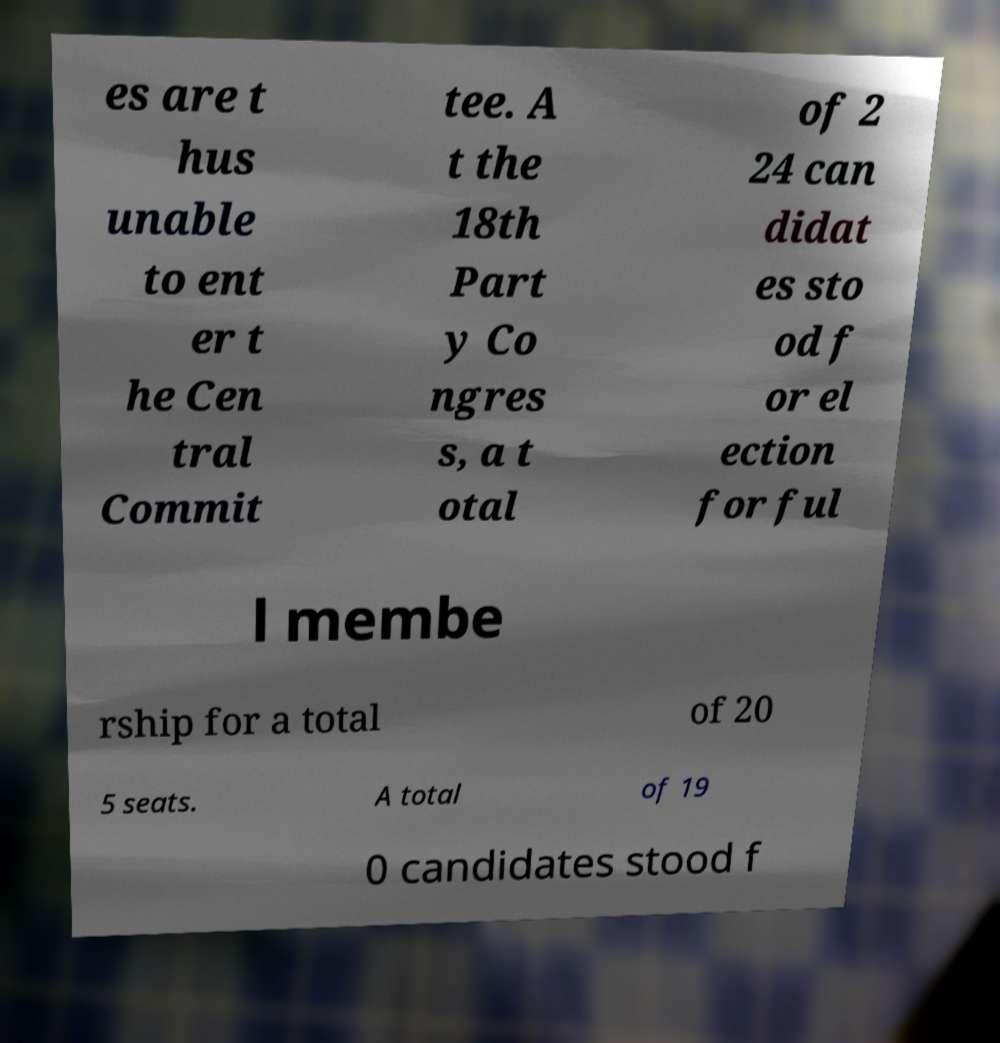Can you accurately transcribe the text from the provided image for me? es are t hus unable to ent er t he Cen tral Commit tee. A t the 18th Part y Co ngres s, a t otal of 2 24 can didat es sto od f or el ection for ful l membe rship for a total of 20 5 seats. A total of 19 0 candidates stood f 